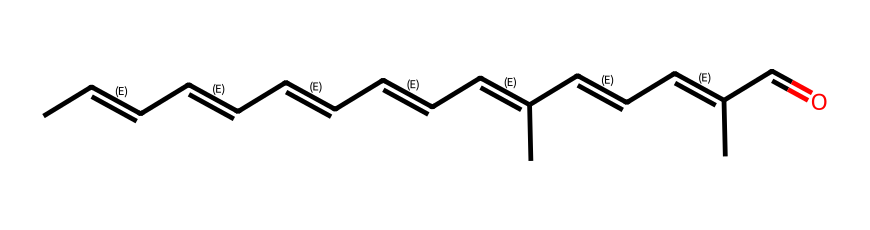What is the chemical name of this compound? This compound has the structure of retinal, a particular isomer of vitamin A, which is critical for vision.
Answer: retinal How many carbon atoms are in this structure? By analyzing the SMILES, it can be observed that there are 20 carbon atoms as indicated by each 'C' appearance in the string.
Answer: 20 What type of isomerism does retinal exhibit? Retinal exhibits geometric isomerism due to the presence of multiple double bonds that can exist in either cis or trans configurations.
Answer: geometric isomerism What specific role does retinal play in human vision? Retinal is essential for the phototransduction process in the retina, allowing the conversion of light into neural signals that are interpreted by the brain.
Answer: phototransduction Which part of the molecule contains the aldehyde functional group? The aldehyde functional group is indicated by the presence of 'C=O' at the end of the molecule, showing that it is bonded to a hydrogen atom.
Answer: C=O How does the geometric configuration of retinal affect its function in vision? The cis and trans configurations of retinal can influence its ability to fit into the binding site of opsins, which are proteins that initiate visual phototransduction.
Answer: influence binding 